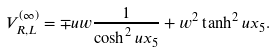<formula> <loc_0><loc_0><loc_500><loc_500>V _ { R , L } ^ { ( \infty ) } = \mp u w \frac { 1 } { \cosh ^ { 2 } u x _ { 5 } } + w ^ { 2 } \tanh ^ { 2 } u x _ { 5 } .</formula> 